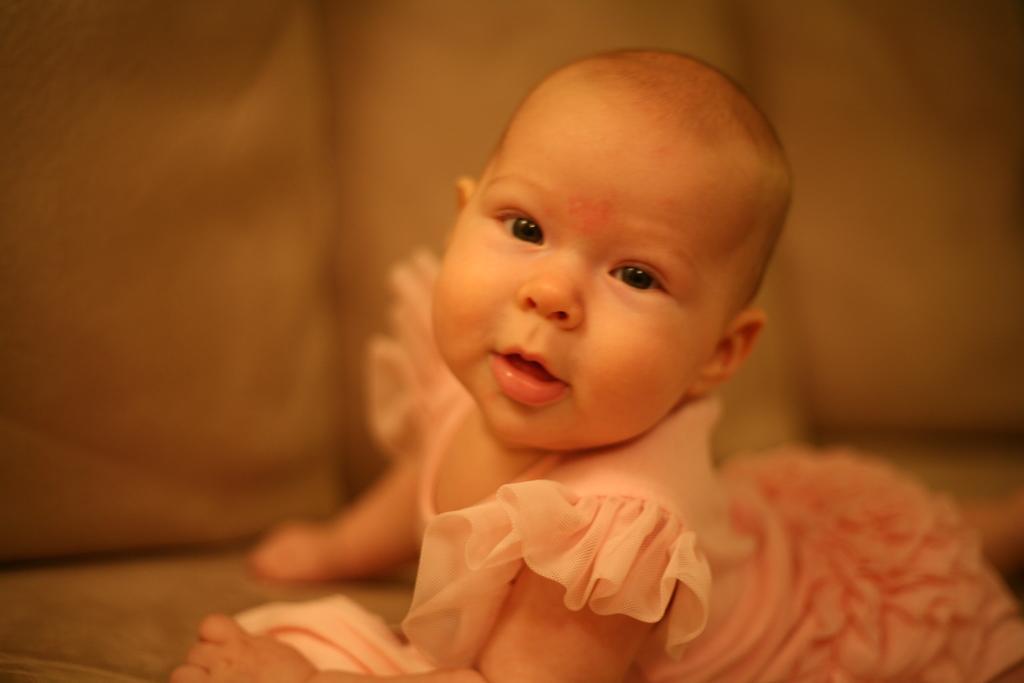Describe this image in one or two sentences. In this picture we can see a baby and in the background it is blurry. 